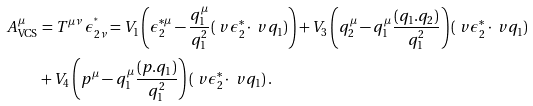<formula> <loc_0><loc_0><loc_500><loc_500>A ^ { \mu } _ { \text {VCS} } & = T ^ { \mu \nu } \, \epsilon _ { 2 \nu } ^ { ^ { * } } = V _ { 1 } \left ( \epsilon _ { 2 } ^ { * \mu } - \frac { q _ { 1 } ^ { \mu } } { q _ { 1 } ^ { 2 } } ( \ v { \epsilon _ { 2 } ^ { * } } \cdot \ v { q _ { 1 } } ) \right ) + V _ { 3 } \left ( q _ { 2 } ^ { \mu } - q _ { 1 } ^ { \mu } \frac { ( q _ { 1 } . q _ { 2 } ) } { q _ { 1 } ^ { 2 } } \right ) ( \ v { \epsilon _ { 2 } ^ { * } } \cdot \ v { q _ { 1 } } ) \\ & + V _ { 4 } \left ( p ^ { \mu } - q _ { 1 } ^ { \mu } \frac { ( p . q _ { 1 } ) } { q _ { 1 } ^ { 2 } } \right ) ( \ v { \epsilon _ { 2 } ^ { * } } \cdot \ v { q _ { 1 } } ) \, .</formula> 